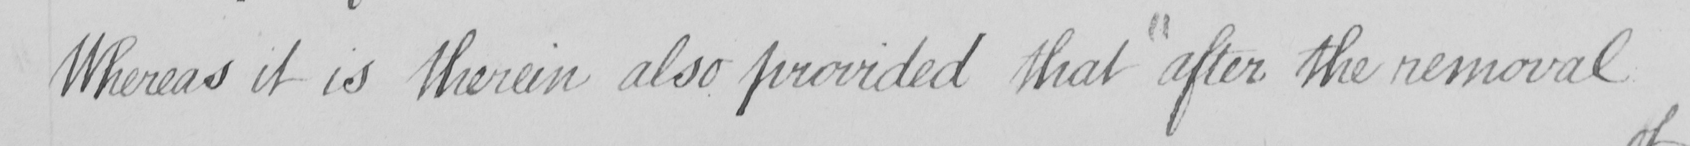Transcribe the text shown in this historical manuscript line. Whereas it is therein also provided that after the removal 